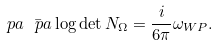Convert formula to latex. <formula><loc_0><loc_0><loc_500><loc_500>\ p a \bar { \ p a } \log \det N _ { \Omega } = \frac { i } { 6 \pi } \omega _ { W P } .</formula> 